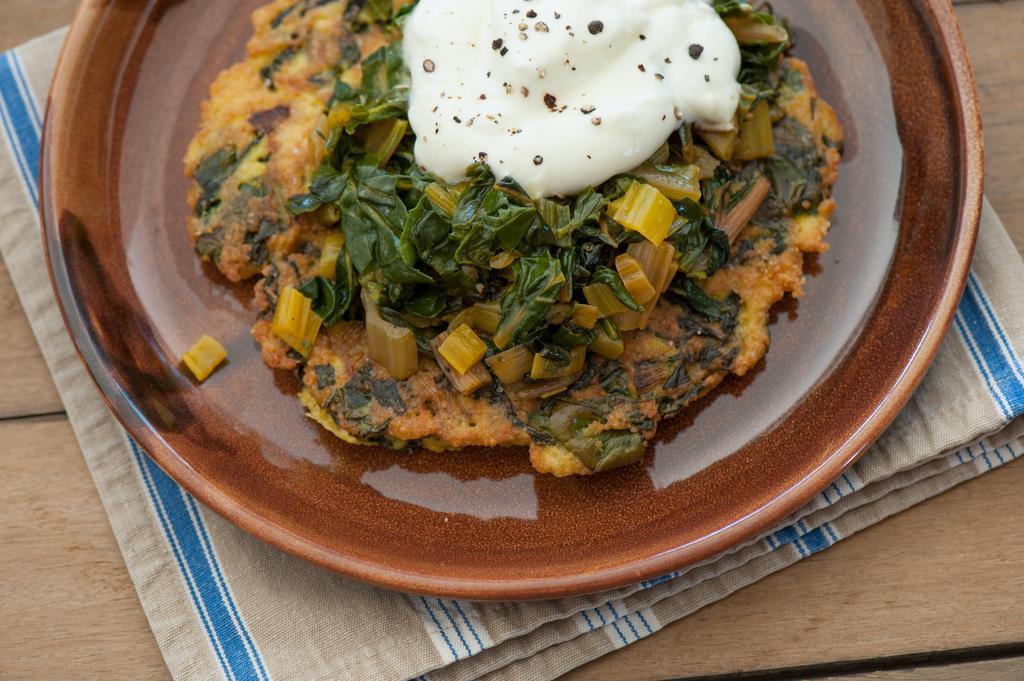In one or two sentences, can you explain what this image depicts? In this picture we can see a plate and a cloth here, at the bottom there is a wooden surface, we can see some food in this plate. 